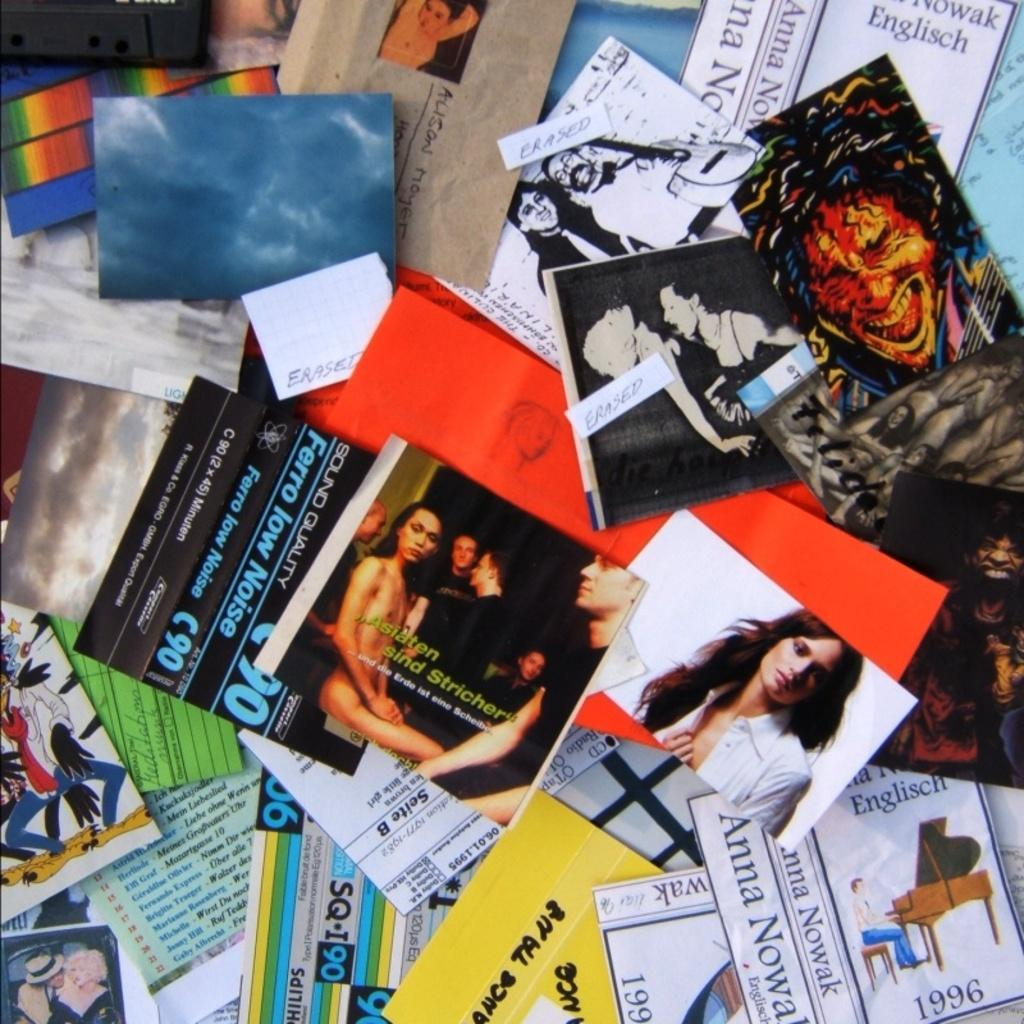<image>
Present a compact description of the photo's key features. A bunch of postcards and CD covers, including one with the words Asiaten sind Stricher on it. 